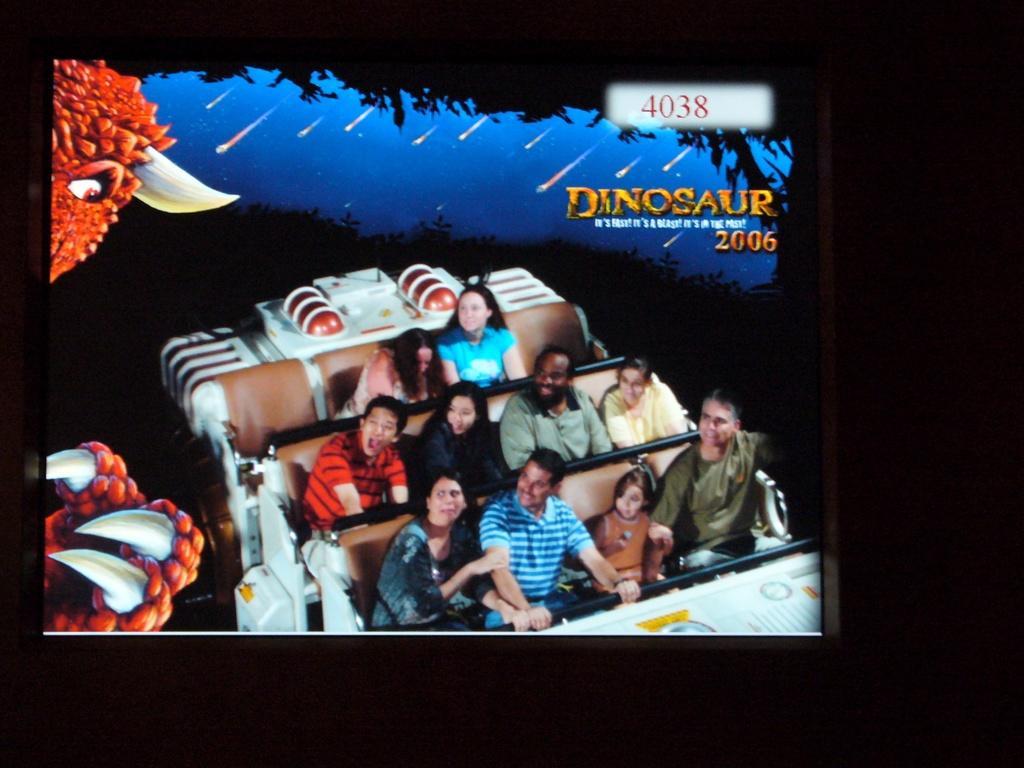Please provide a concise description of this image. In this image I can see there are number of persons sitting in the vesicle and on the right side corner I can see a text written in the image. on the left side corner there is a eye. 